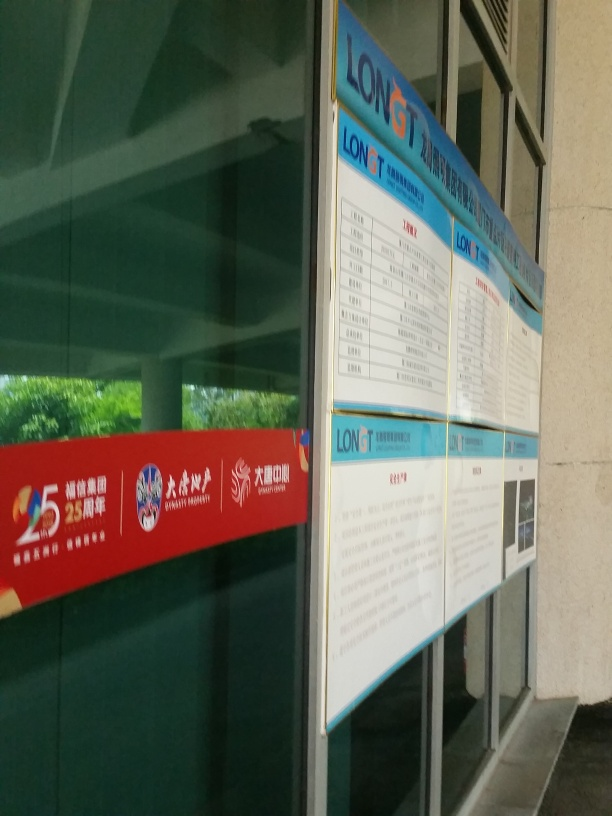What information is displayed on the board? The board appears to be a schedule or an information panel, possibly for transportation services like bus or train times, although the image is not clear enough to read the specific details. Can you tell what the blue and white color scheme of the board represents? The blue and white color scheme of the board gives it a clean and professional appearance. It could represent corporate branding or simply be a design choice for clarity and visibility. 